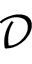<formula> <loc_0><loc_0><loc_500><loc_500>\mathcal { D }</formula> 